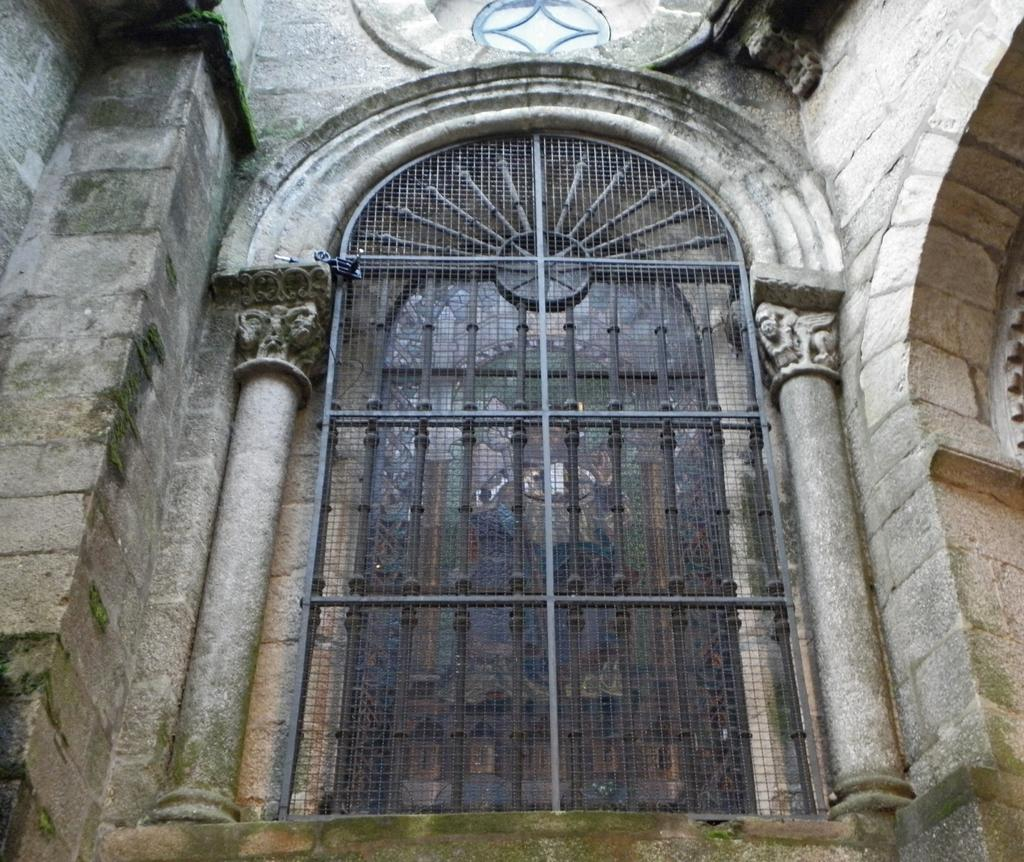What type of architectural feature is visible in the image? There is a window in the image. What kind of building does the window belong to? The window belongs to a monumental building. How is the window protected or secured? The window is covered with an iron gate. Is there any other entrance feature associated with the window? Yes, there is a door present over the window. How many rings are being distributed by the window in the image? There are no rings being distributed in the image; it features a window with an iron gate and a door. 